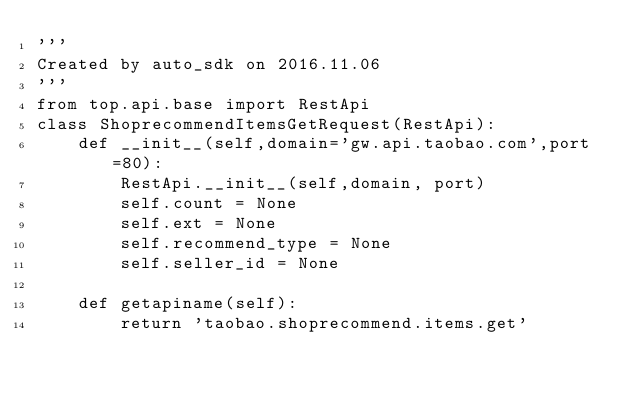Convert code to text. <code><loc_0><loc_0><loc_500><loc_500><_Python_>'''
Created by auto_sdk on 2016.11.06
'''
from top.api.base import RestApi
class ShoprecommendItemsGetRequest(RestApi):
	def __init__(self,domain='gw.api.taobao.com',port=80):
		RestApi.__init__(self,domain, port)
		self.count = None
		self.ext = None
		self.recommend_type = None
		self.seller_id = None

	def getapiname(self):
		return 'taobao.shoprecommend.items.get'
</code> 